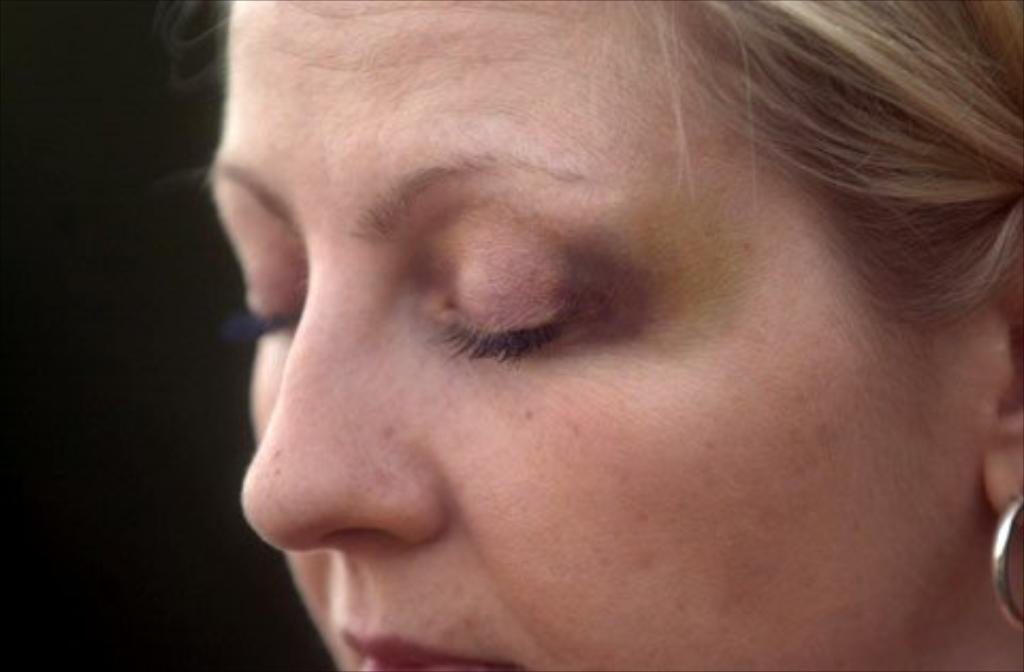What is the main subject of the image? The main subject of the image is a woman. What accessory is the woman wearing in the image? The woman is wearing earrings in the image. What type of underwear is the woman wearing in the image? There is no information about the woman's underwear in the image, so it cannot be determined. 